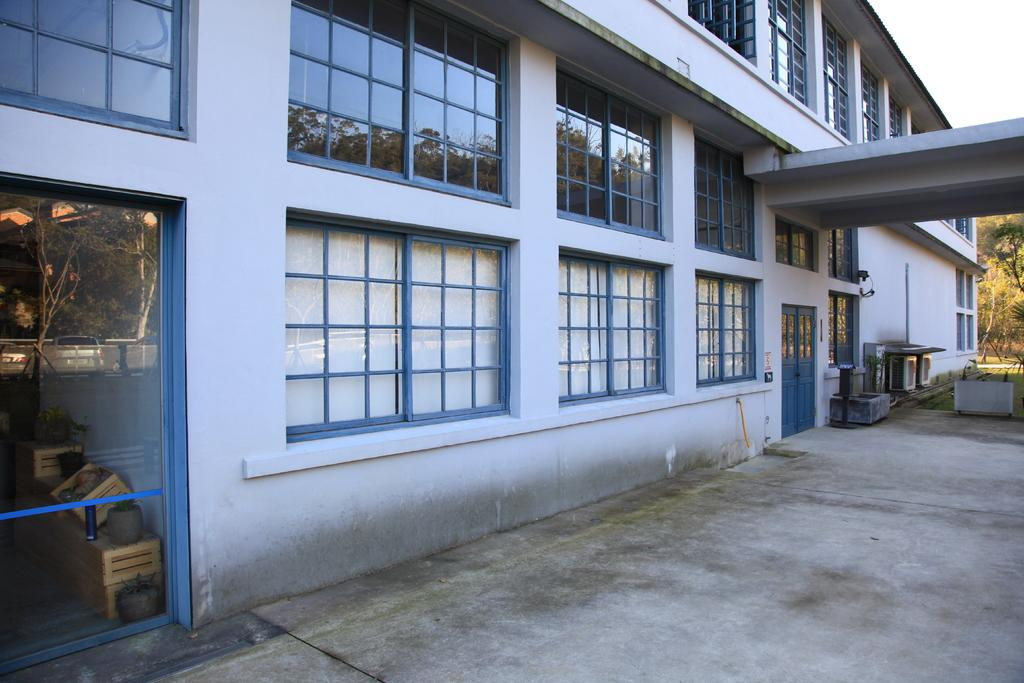What is the main structure in the image? There is a building in the image. What architectural feature can be observed on the building? The building has plenty of windows. How many doors are visible on the building? The building has two doors. What type of vegetation is visible behind the building? There are trees behind the building. What type of line is visible on the building in the image? There is no line visible on the building in the image. What type of suit is hanging in the window of the building? There is no suit visible in the image, as it only shows the building's exterior. 